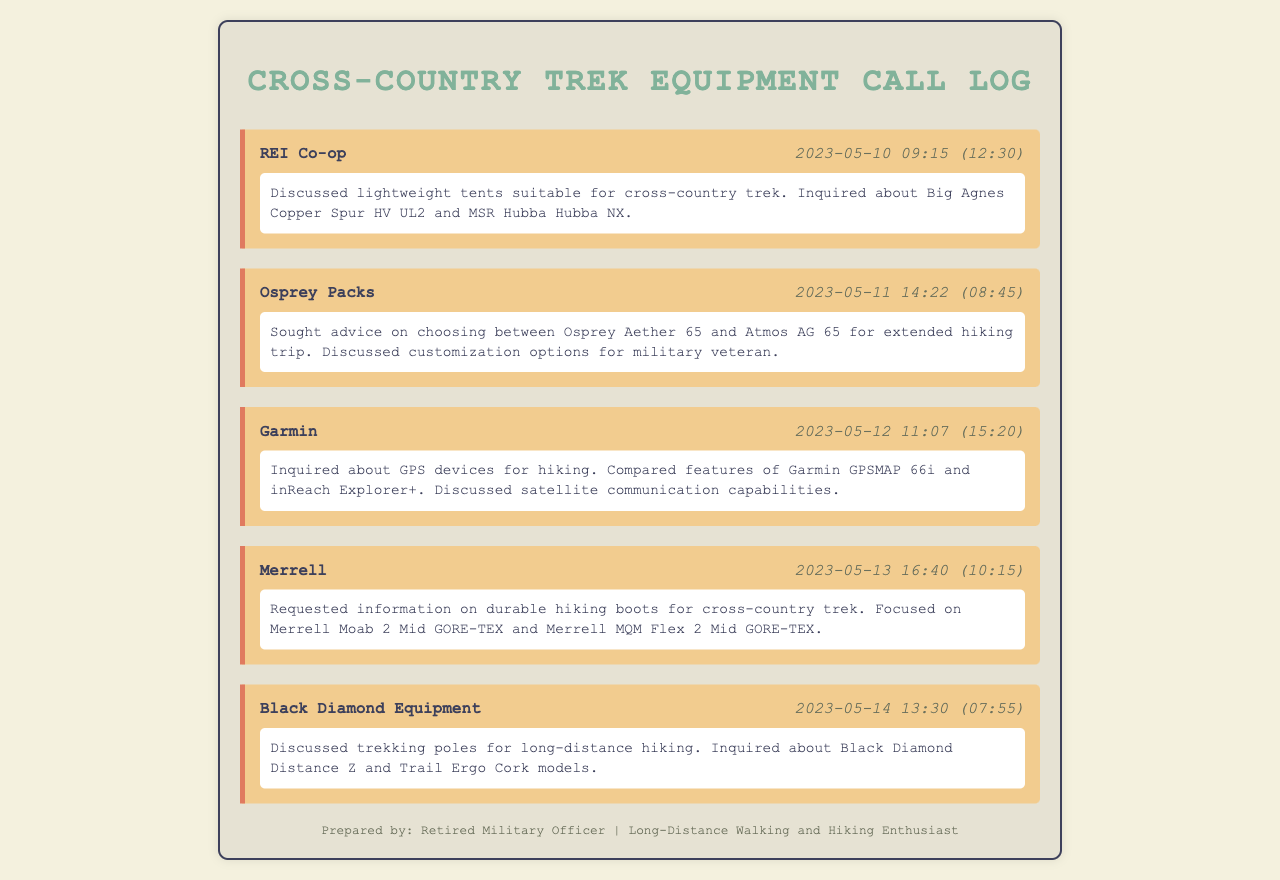What was discussed with REI Co-op? The log notes that lightweight tents suitable for cross-country trek were discussed, specifically inquiring about Big Agnes Copper Spur HV UL2 and MSR Hubba Hubba NX.
Answer: Lightweight tents What equipment was discussed with Osprey Packs? The conversation revolved around choosing between Osprey Aether 65 and Atmos AG 65 for an extended hiking trip.
Answer: Osprey Aether 65 and Atmos AG 65 Which GPS devices were compared during the call with Garmin? The conversation compared features of Garmin GPSMAP 66i and inReach Explorer+.
Answer: Garmin GPSMAP 66i and inReach Explorer+ What type of boots did Merrell provide information on? Information was requested on durable hiking boots for a cross-country trek, specifically focusing on Merrell Moab 2 Mid GORE-TEX and Merrell MQM Flex 2 Mid GORE-TEX.
Answer: Durable hiking boots What is one model of trekking poles discussed with Black Diamond Equipment? The log mentions the Black Diamond Distance Z model among trekking poles discussed.
Answer: Black Diamond Distance Z When was the call to Osprey Packs made? The call to Osprey Packs took place on May 11, 2023.
Answer: 2023-05-11 How long was the call with Garmin? The duration of the call with Garmin was 15 minutes and 20 seconds.
Answer: 15:20 What aspect of gear was specifically discussed with Black Diamond Equipment? The discussion focused on trekking poles for long-distance hiking.
Answer: Trekking poles 